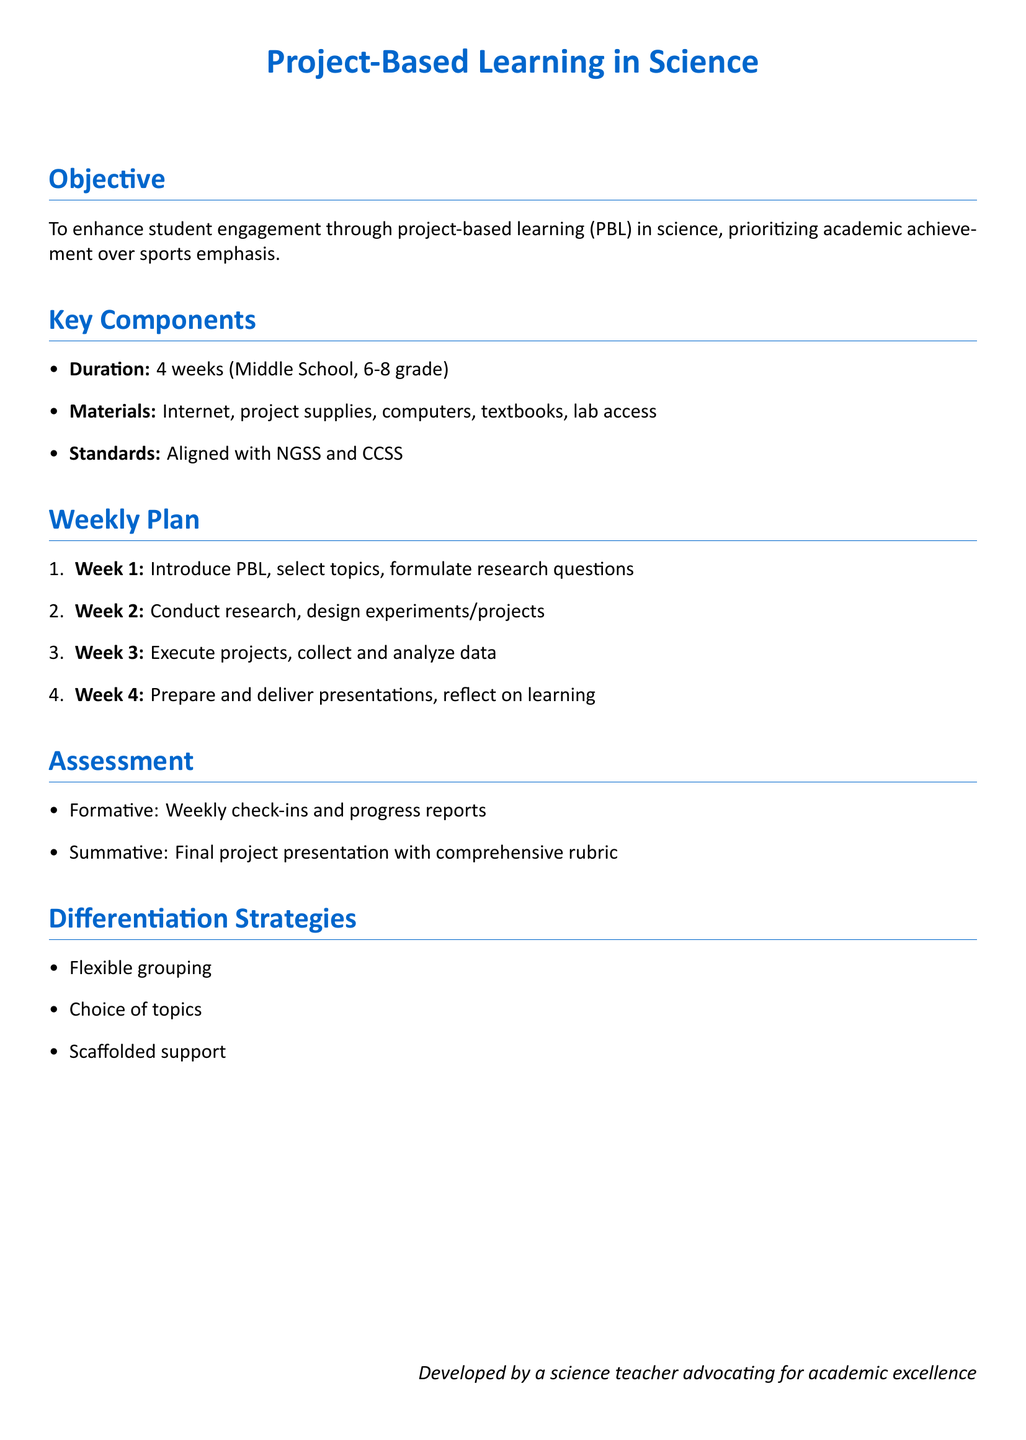What is the duration of the project? The duration of the project is clearly stated in the document as 4 weeks.
Answer: 4 weeks What grades is the lesson plan designed for? The document specifies that the lesson plan is for Middle School, grades 6-8.
Answer: 6-8 grade What are the key materials needed? The document lists essential materials like Internet, project supplies, computers, textbooks, and lab access.
Answer: Internet, project supplies, computers, textbooks, lab access What is the first activity of Week 1? The first activity mentioned for Week 1 is to introduce PBL and select topics.
Answer: Introduce PBL, select topics How is student progress assessed? The document outlines assessment methods, indicating that formative assessments are through weekly check-ins and progress reports.
Answer: Weekly check-ins and progress reports What is one differentiation strategy mentioned? The document includes various differentiation strategies, one of which is flexible grouping.
Answer: Flexible grouping What type of learning does this lesson plan focus on? The focus of the lesson plan is on integrating project-based learning (PBL) in science.
Answer: Project-based learning (PBL) When are presentations prepared and delivered? According to the weekly plan, presentations are prepared and delivered in Week 4.
Answer: Week 4 